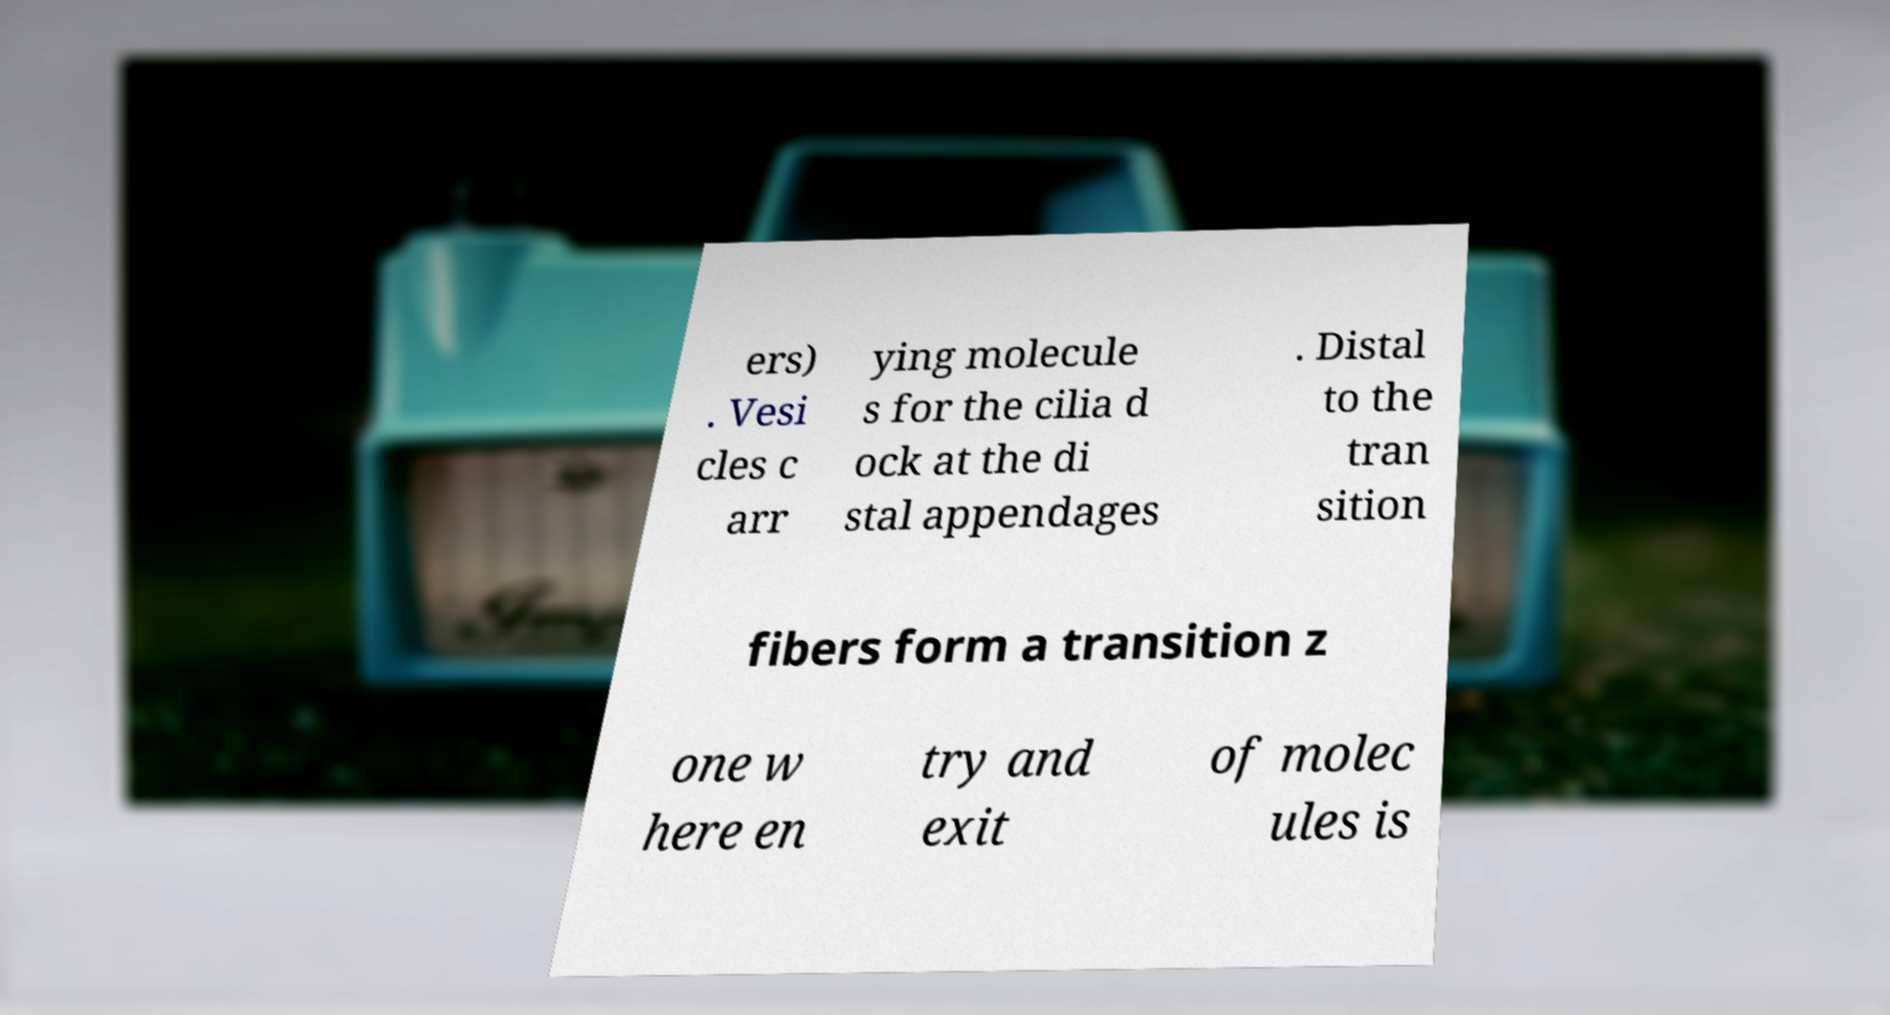Could you assist in decoding the text presented in this image and type it out clearly? ers) . Vesi cles c arr ying molecule s for the cilia d ock at the di stal appendages . Distal to the tran sition fibers form a transition z one w here en try and exit of molec ules is 